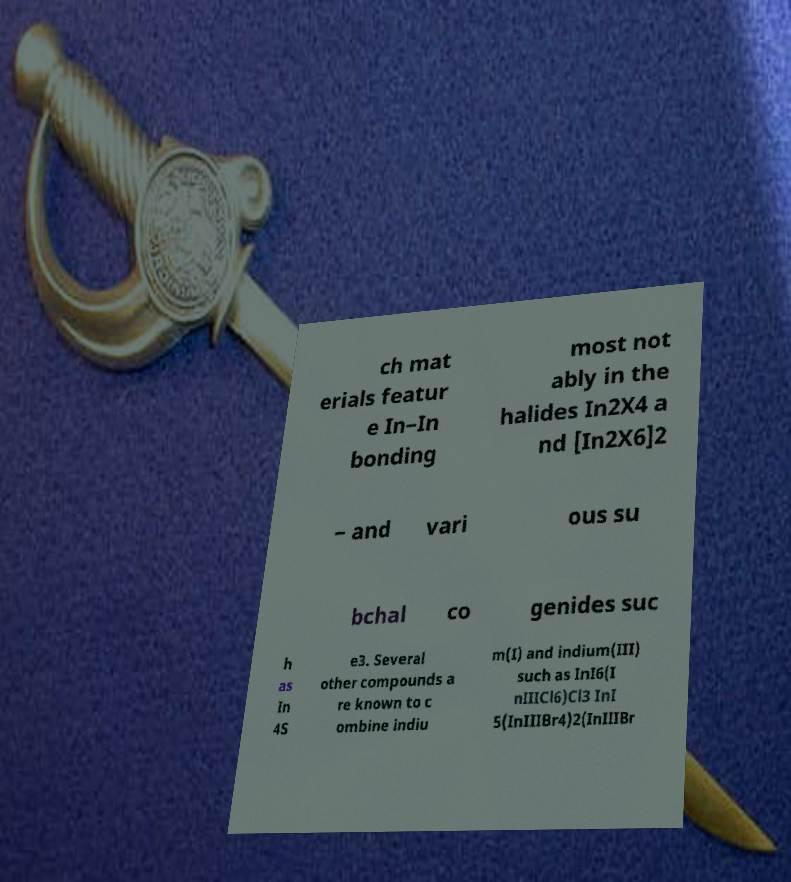I need the written content from this picture converted into text. Can you do that? ch mat erials featur e In–In bonding most not ably in the halides In2X4 a nd [In2X6]2 − and vari ous su bchal co genides suc h as In 4S e3. Several other compounds a re known to c ombine indiu m(I) and indium(III) such as InI6(I nIIICl6)Cl3 InI 5(InIIIBr4)2(InIIIBr 